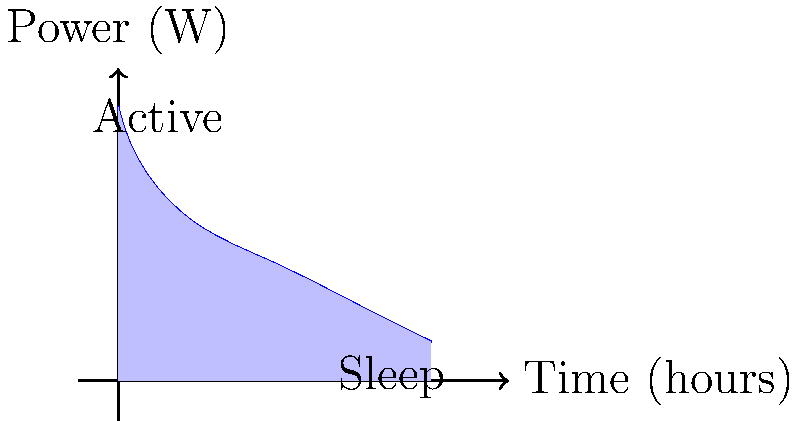As a wildlife conservationist, you need to design an energy-efficient circuit for a tracking device to monitor endangered species in the Amazon rainforest. The device alternates between active and sleep modes to conserve power. Given the power consumption curve shown in the graph, calculate the total energy consumed by the device over the 4-hour period. Assume the vertical axis represents power in watts and the horizontal axis represents time in hours. To calculate the total energy consumed, we need to find the area under the power consumption curve. Let's break this down step-by-step:

1. The energy consumed is equal to the integral of power over time: $E = \int_{0}^{4} P(t) dt$

2. We can approximate this integral by dividing the area under the curve into geometric shapes:
   a. A triangle for the first 2 hours (active mode)
   b. A trapezoid for the last 2 hours (sleep mode)

3. For the triangle (0-2 hours):
   Base = 2 hours
   Height = 3.5 W - 1.5 W = 2 W
   Area = $\frac{1}{2} \times 2 \times 2 = 2$ Wh

4. For the trapezoid (2-4 hours):
   Bases = 1.5 W and 0.5 W
   Height = 2 hours
   Area = $\frac{1.5 + 0.5}{2} \times 2 = 2$ Wh

5. Total energy = Triangle area + Trapezoid area
                = 2 Wh + 2 Wh = 4 Wh

Therefore, the total energy consumed by the device over the 4-hour period is 4 watt-hours (Wh).
Answer: 4 Wh 